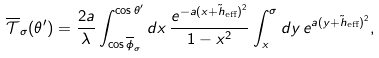<formula> <loc_0><loc_0><loc_500><loc_500>\overline { \mathcal { T } } _ { \sigma } ( \theta ^ { \prime } ) = \frac { 2 a } { \lambda } \int _ { \cos \overline { \phi } _ { \sigma } } ^ { \cos \theta ^ { \prime } } d x \, \frac { e ^ { - a ( x + \tilde { h } _ { \text {eff} } ) ^ { 2 } } } { 1 - x ^ { 2 } } \int _ { x } ^ { \sigma } d y \, e ^ { a ( y + \tilde { h } _ { \text {eff} } ) ^ { 2 } } ,</formula> 